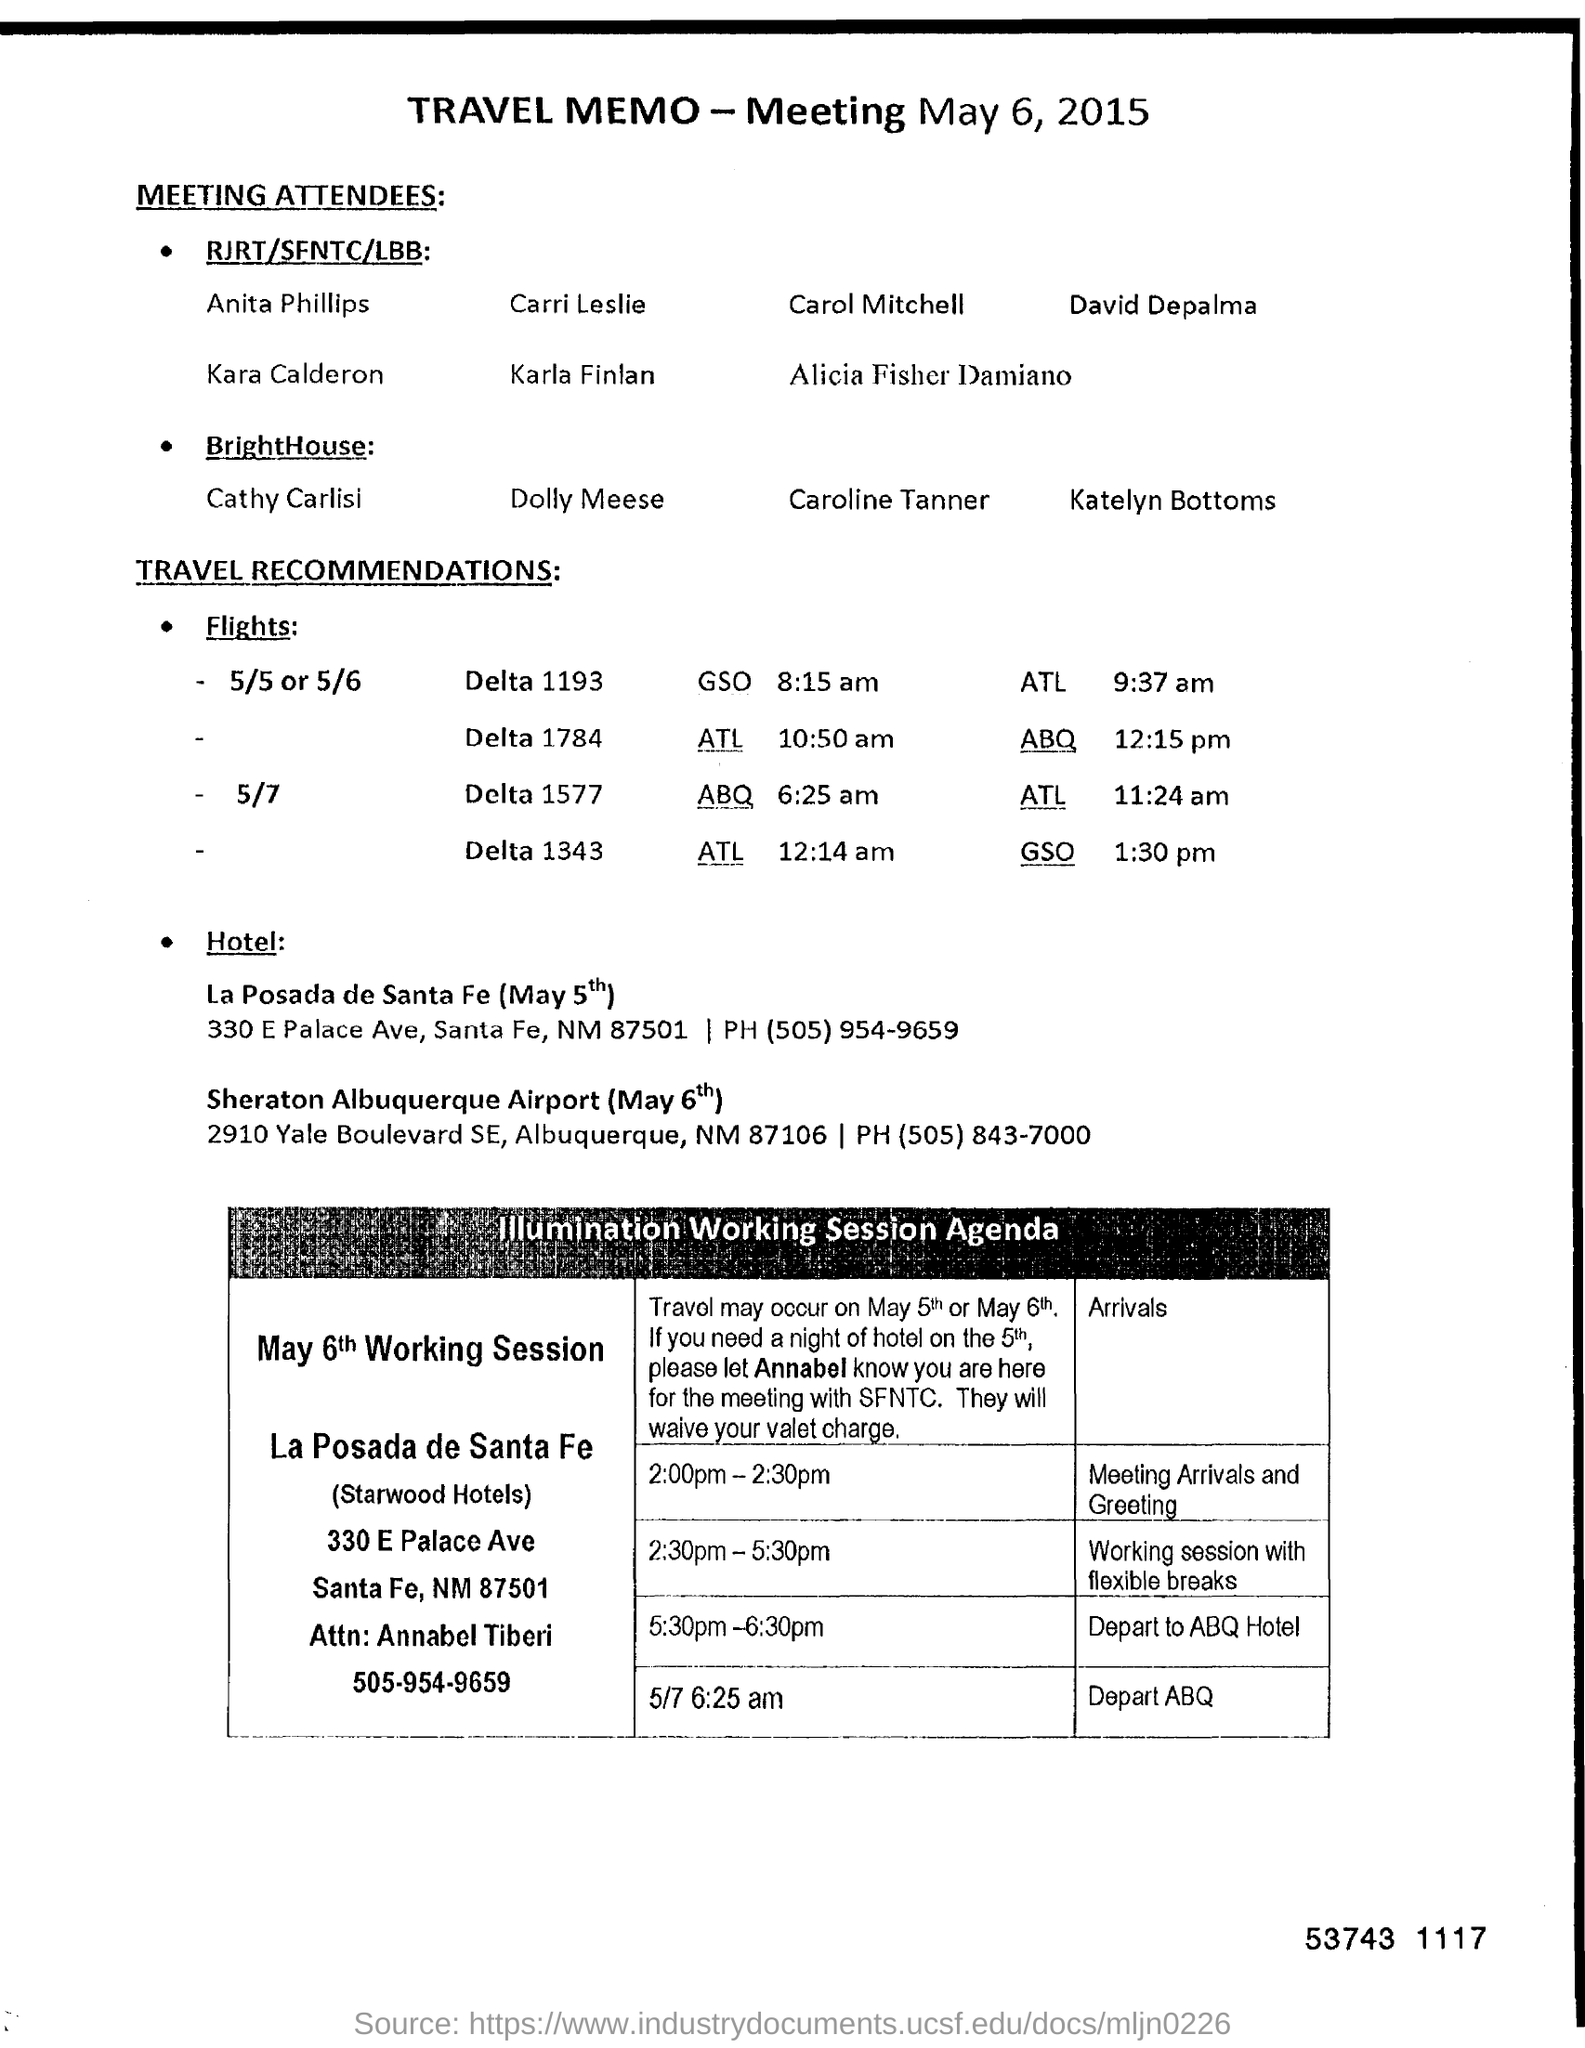Identify some key points in this picture. Annabel Tiberi's contact number is 505-954-9659. 